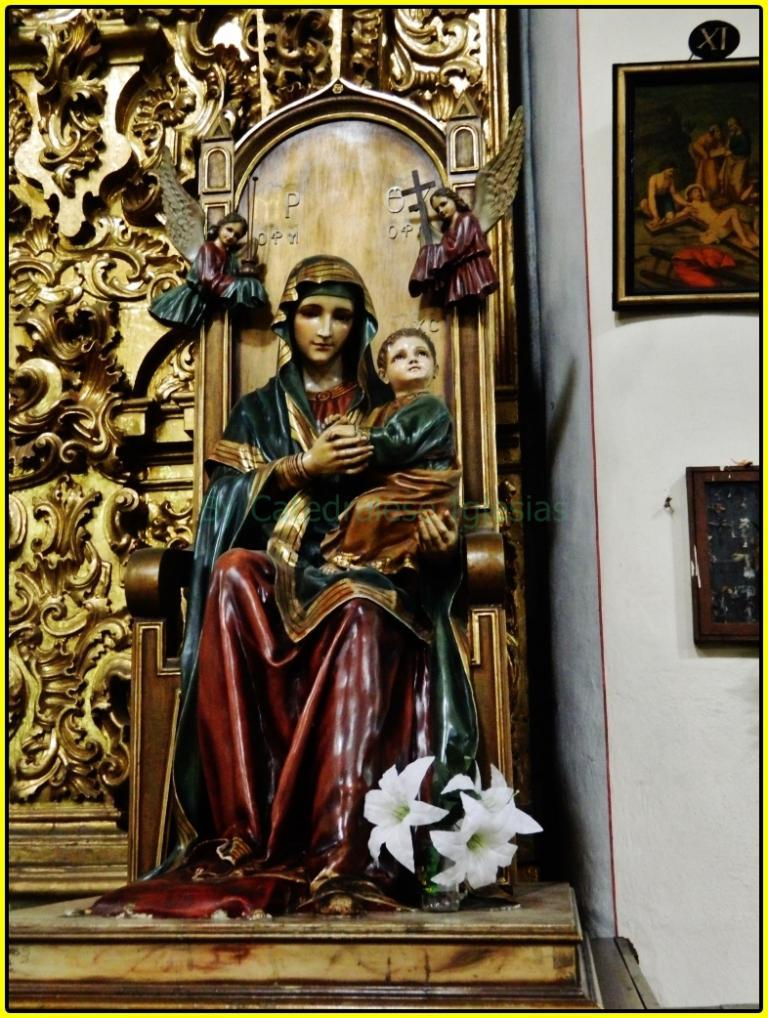What type of objects can be seen attached to the wall in the image? There are statues and wall hangings in the image that are attached to the wall. How are the statues positioned in the image? The statues are attached to the wall in the image. What else is attached to the wall in the image besides the statues? There are wall hangings attached to the wall in the image. What type of toothpaste is being used to push the worm in the image? There is no toothpaste or worm present in the image. 